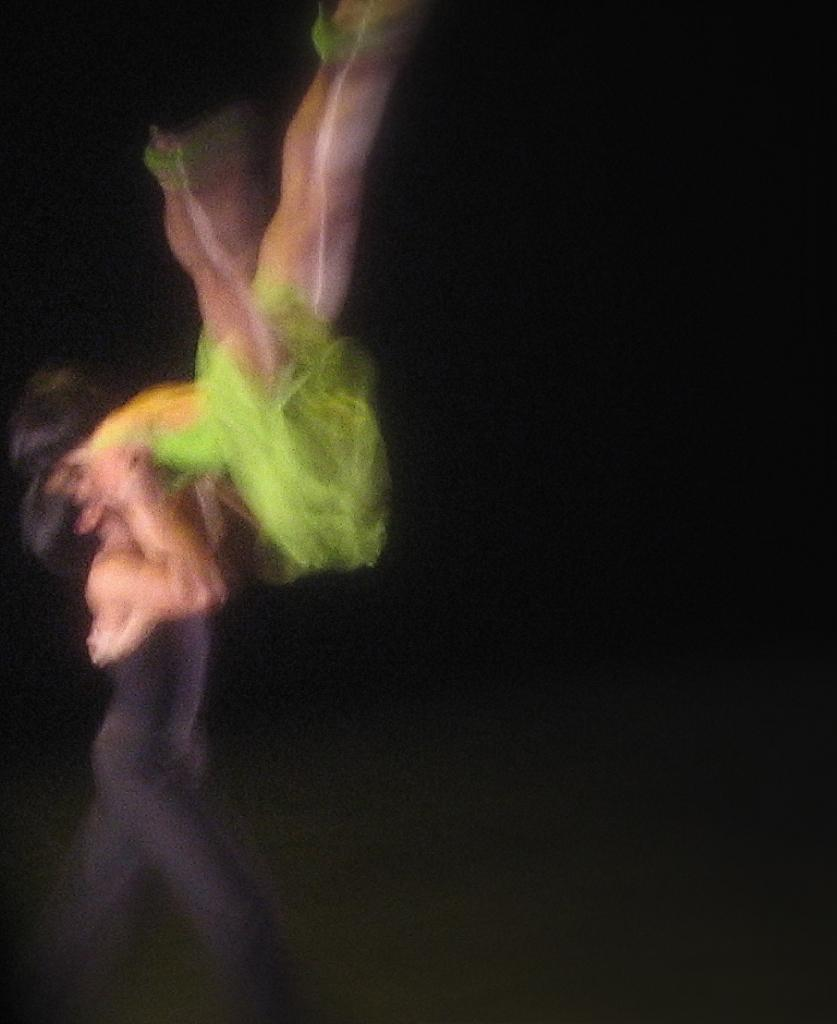How many people are in the image? There are persons in the image, but the exact number is not specified. What can be observed about the background of the image? The background of the image is dark. What type of ray is visible in the image? There is no ray present in the image. What is the relationship between the persons in the image? The relationship between the persons in the image is not specified in the facts. What type of polish is being applied in the image? There is no mention of polish or any activity involving polish in the image. 